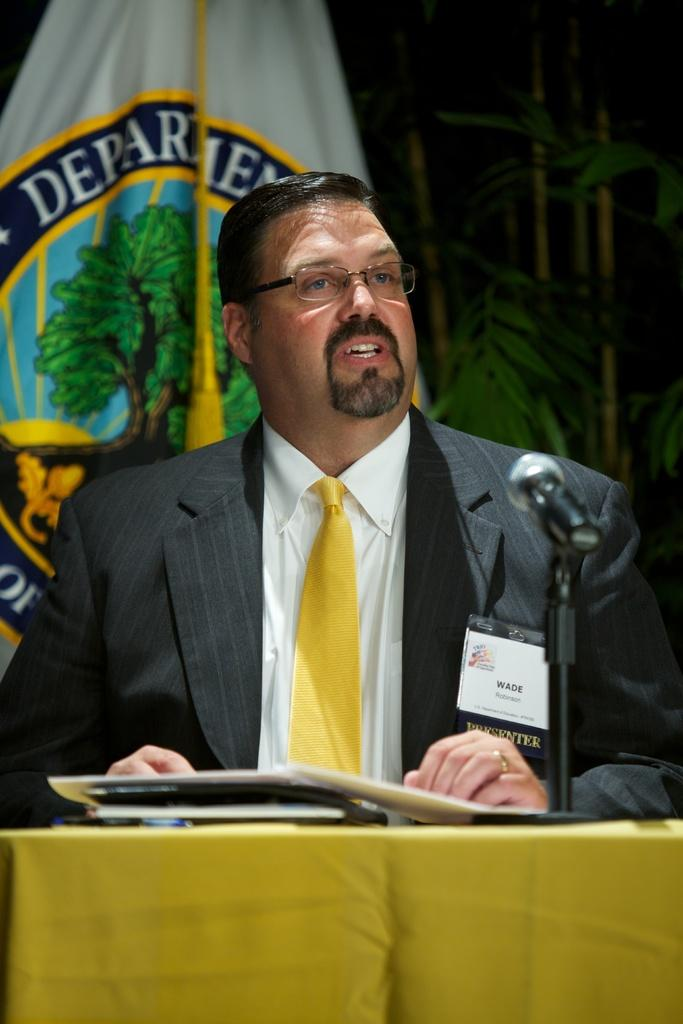What is the man in the image doing? The man is standing near a microphone. What object can be seen on the table in the image? The provided facts do not mention any specific object on the table. What is located behind the man in the image? There is a tree behind the man. What type of sidewalk can be seen in the image? There is no sidewalk present in the image. 